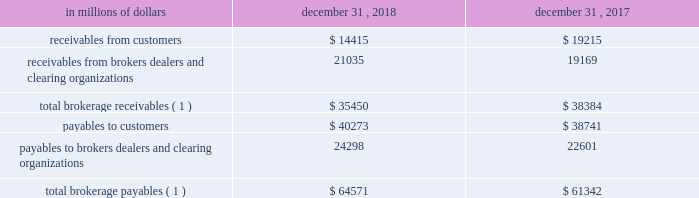12 .
Brokerage receivables and brokerage payables the company has receivables and payables for financial instruments sold to and purchased from brokers , dealers and customers , which arise in the ordinary course of business .
Citi is exposed to risk of loss from the inability of brokers , dealers or customers to pay for purchases or to deliver the financial instruments sold , in which case citi would have to sell or purchase the financial instruments at prevailing market prices .
Credit risk is reduced to the extent that an exchange or clearing organization acts as a counterparty to the transaction and replaces the broker , dealer or customer in question .
Citi seeks to protect itself from the risks associated with customer activities by requiring customers to maintain margin collateral in compliance with regulatory and internal guidelines .
Margin levels are monitored daily , and customers deposit additional collateral as required .
Where customers cannot meet collateral requirements , citi may liquidate sufficient underlying financial instruments to bring the customer into compliance with the required margin level .
Exposure to credit risk is impacted by market volatility , which may impair the ability of clients to satisfy their obligations to citi .
Credit limits are established and closely monitored for customers and for brokers and dealers engaged in forwards , futures and other transactions deemed to be credit sensitive .
Brokerage receivables and brokerage payables consisted of the following: .
Total brokerage payables ( 1 ) $ 64571 $ 61342 ( 1 ) includes brokerage receivables and payables recorded by citi broker-dealer entities that are accounted for in accordance with the aicpa accounting guide for brokers and dealers in securities as codified in asc 940-320. .
What percentage of total brokerage payables at december 31 , 2018 where receivables from customers? 
Computations: (14415 / 64571)
Answer: 0.22324. 